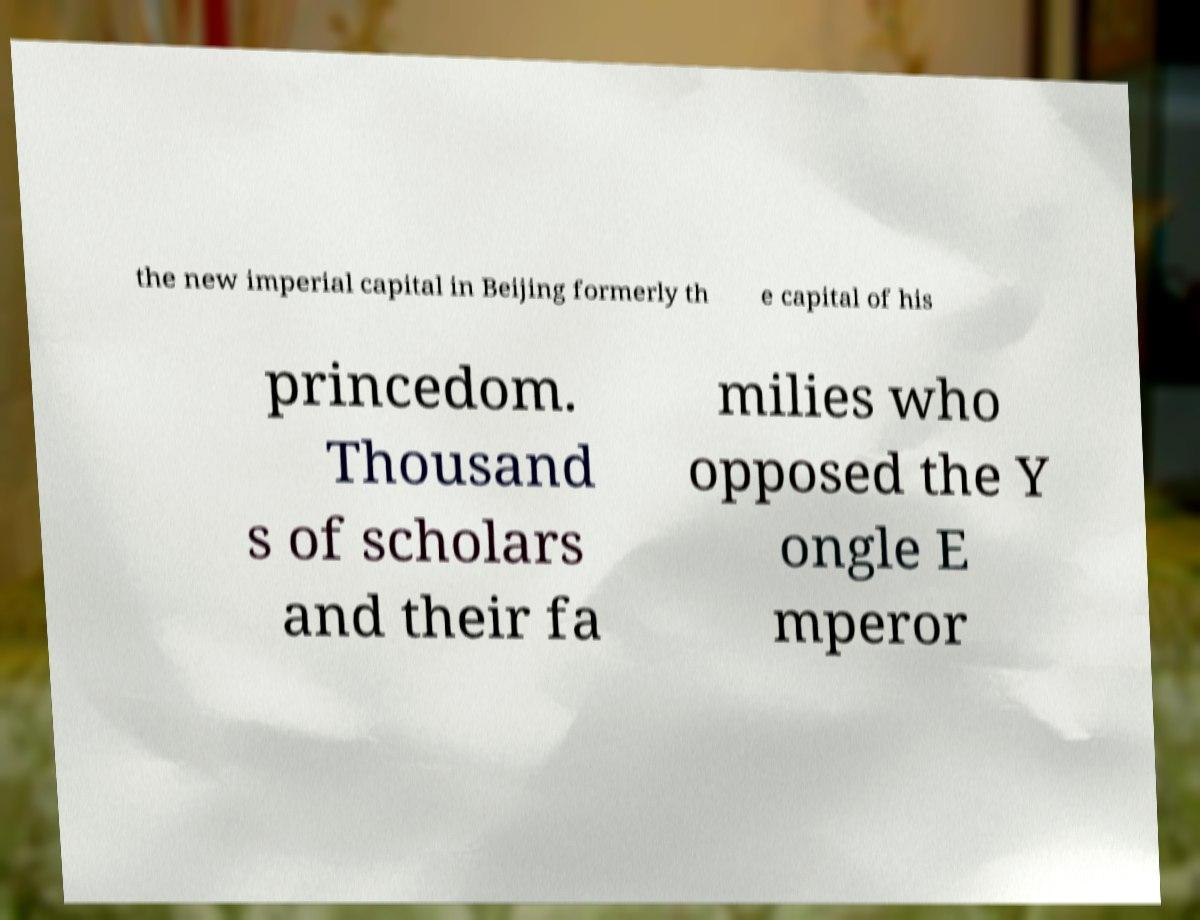Please read and relay the text visible in this image. What does it say? the new imperial capital in Beijing formerly th e capital of his princedom. Thousand s of scholars and their fa milies who opposed the Y ongle E mperor 